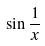Convert formula to latex. <formula><loc_0><loc_0><loc_500><loc_500>\sin \frac { 1 } { x }</formula> 